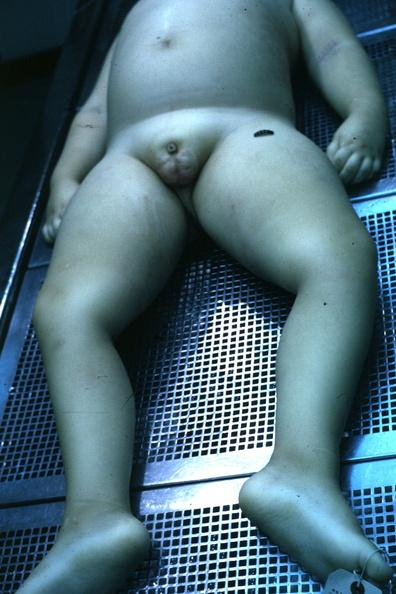s underdevelopment present?
Answer the question using a single word or phrase. Yes 